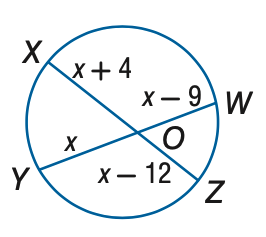Question: Find x to the nearest tenth. Assume that segments that appear to be tangent are tangent.
Choices:
A. 24
B. 36
C. 48
D. 60
Answer with the letter. Answer: C 